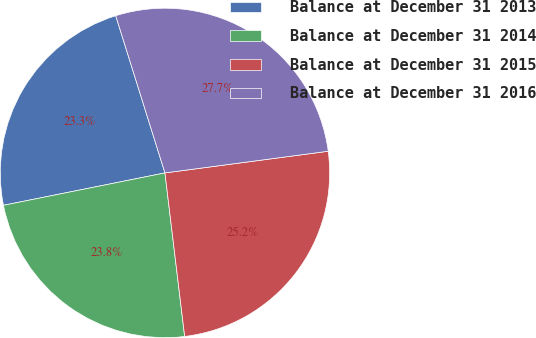<chart> <loc_0><loc_0><loc_500><loc_500><pie_chart><fcel>Balance at December 31 2013<fcel>Balance at December 31 2014<fcel>Balance at December 31 2015<fcel>Balance at December 31 2016<nl><fcel>23.32%<fcel>23.76%<fcel>25.19%<fcel>27.73%<nl></chart> 